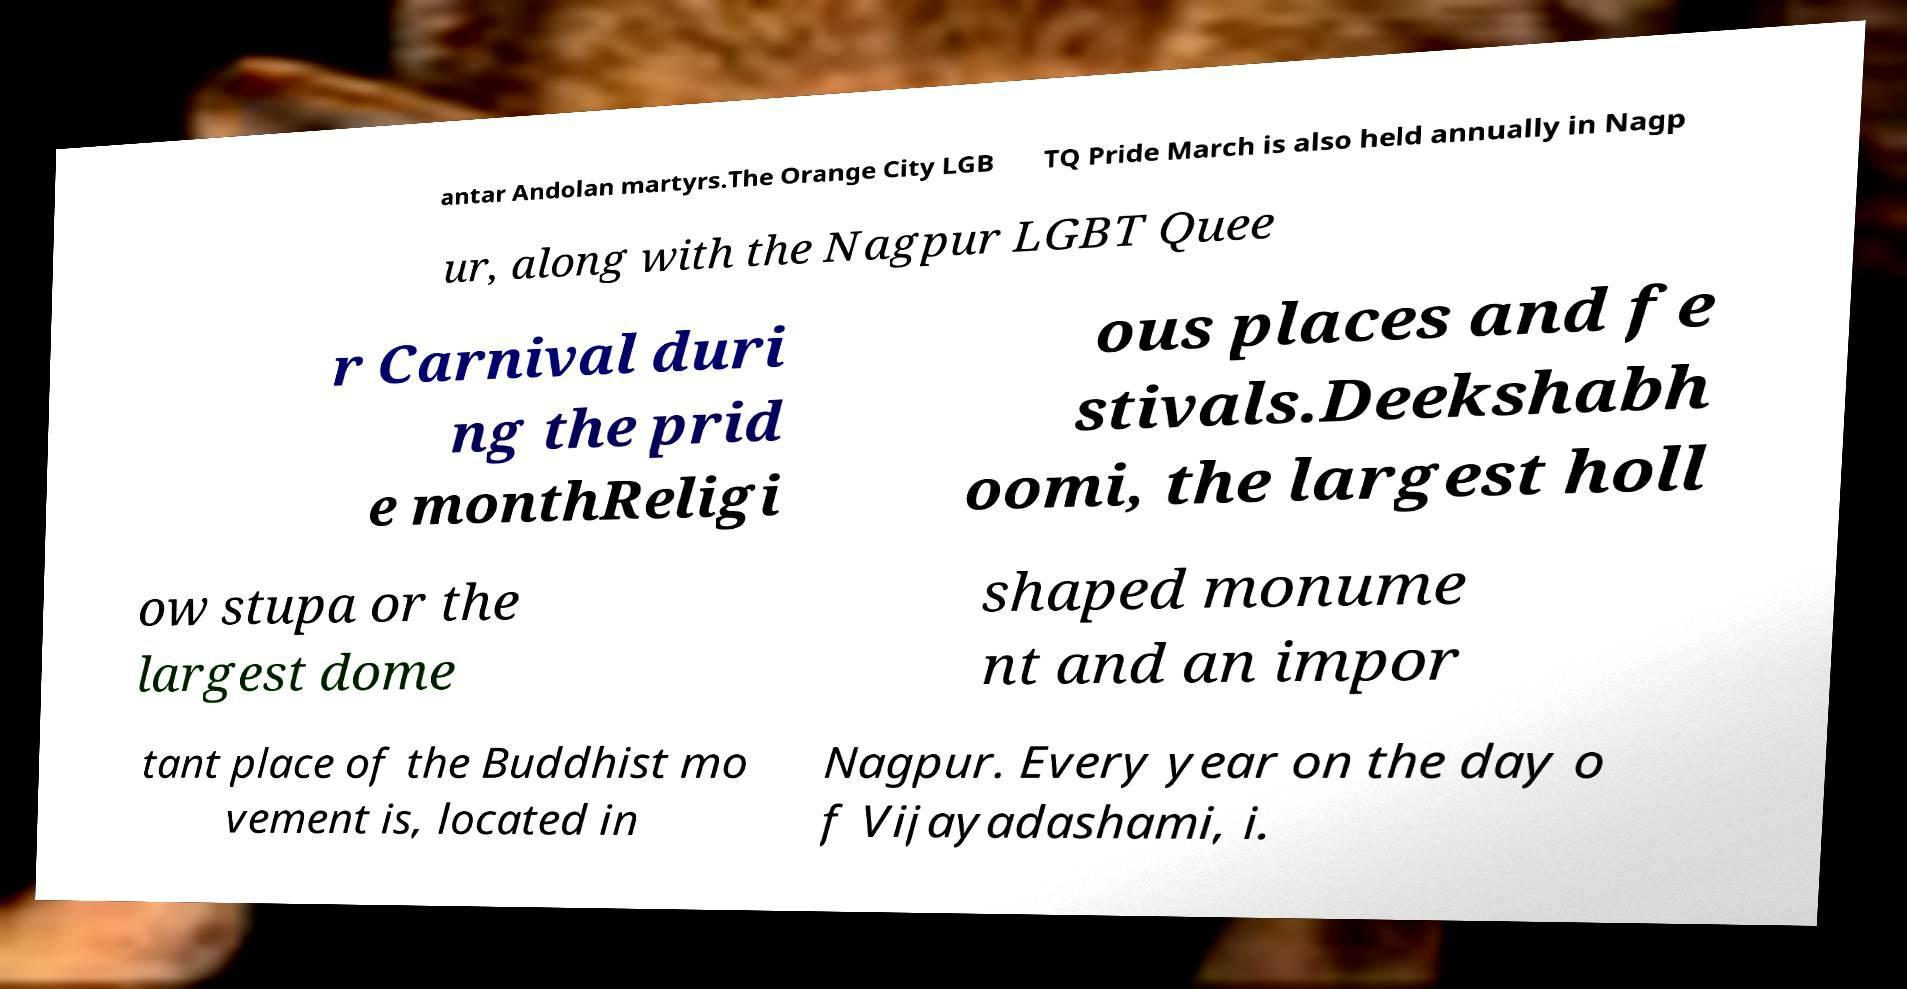Could you assist in decoding the text presented in this image and type it out clearly? antar Andolan martyrs.The Orange City LGB TQ Pride March is also held annually in Nagp ur, along with the Nagpur LGBT Quee r Carnival duri ng the prid e monthReligi ous places and fe stivals.Deekshabh oomi, the largest holl ow stupa or the largest dome shaped monume nt and an impor tant place of the Buddhist mo vement is, located in Nagpur. Every year on the day o f Vijayadashami, i. 